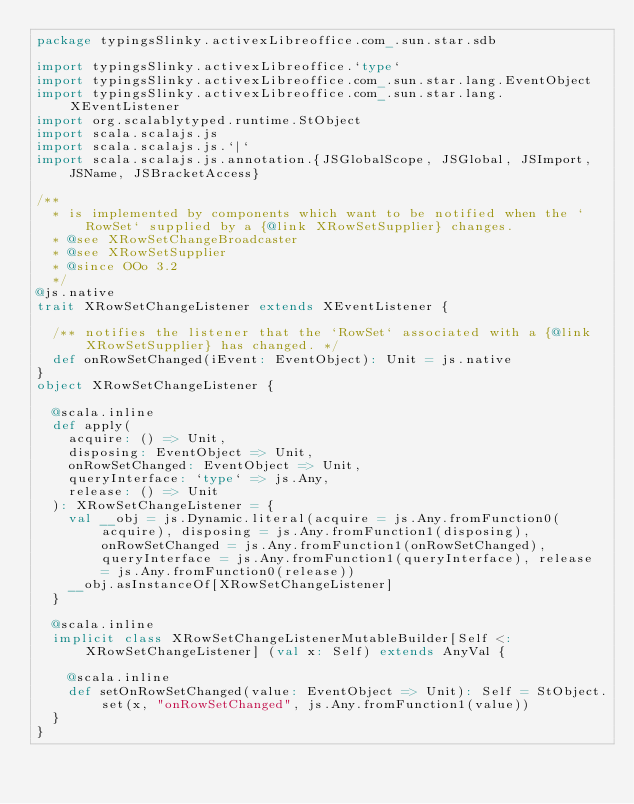<code> <loc_0><loc_0><loc_500><loc_500><_Scala_>package typingsSlinky.activexLibreoffice.com_.sun.star.sdb

import typingsSlinky.activexLibreoffice.`type`
import typingsSlinky.activexLibreoffice.com_.sun.star.lang.EventObject
import typingsSlinky.activexLibreoffice.com_.sun.star.lang.XEventListener
import org.scalablytyped.runtime.StObject
import scala.scalajs.js
import scala.scalajs.js.`|`
import scala.scalajs.js.annotation.{JSGlobalScope, JSGlobal, JSImport, JSName, JSBracketAccess}

/**
  * is implemented by components which want to be notified when the `RowSet` supplied by a {@link XRowSetSupplier} changes.
  * @see XRowSetChangeBroadcaster
  * @see XRowSetSupplier
  * @since OOo 3.2
  */
@js.native
trait XRowSetChangeListener extends XEventListener {
  
  /** notifies the listener that the `RowSet` associated with a {@link XRowSetSupplier} has changed. */
  def onRowSetChanged(iEvent: EventObject): Unit = js.native
}
object XRowSetChangeListener {
  
  @scala.inline
  def apply(
    acquire: () => Unit,
    disposing: EventObject => Unit,
    onRowSetChanged: EventObject => Unit,
    queryInterface: `type` => js.Any,
    release: () => Unit
  ): XRowSetChangeListener = {
    val __obj = js.Dynamic.literal(acquire = js.Any.fromFunction0(acquire), disposing = js.Any.fromFunction1(disposing), onRowSetChanged = js.Any.fromFunction1(onRowSetChanged), queryInterface = js.Any.fromFunction1(queryInterface), release = js.Any.fromFunction0(release))
    __obj.asInstanceOf[XRowSetChangeListener]
  }
  
  @scala.inline
  implicit class XRowSetChangeListenerMutableBuilder[Self <: XRowSetChangeListener] (val x: Self) extends AnyVal {
    
    @scala.inline
    def setOnRowSetChanged(value: EventObject => Unit): Self = StObject.set(x, "onRowSetChanged", js.Any.fromFunction1(value))
  }
}
</code> 